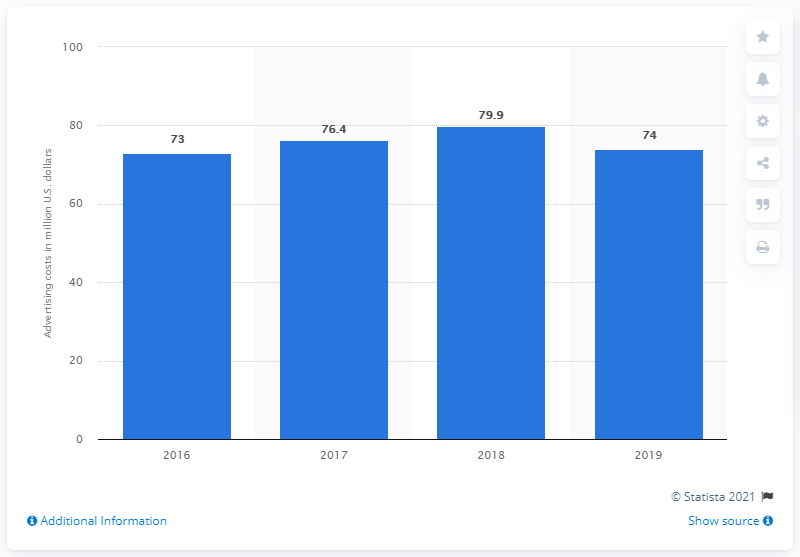List a handful of essential elements in this visual. In 2019, the advertising cost of Ross Stores, Inc. was $74 million. 